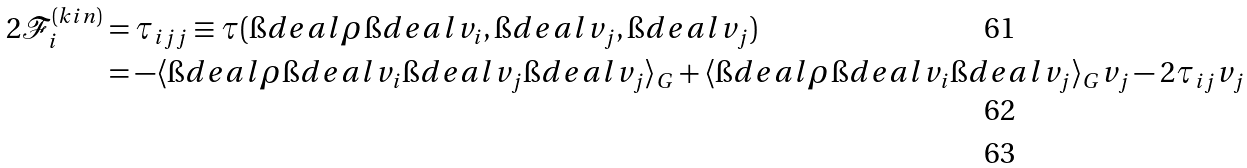<formula> <loc_0><loc_0><loc_500><loc_500>2 \mathcal { F } _ { i } ^ { ( k i n ) } & = \tau _ { i j j } \equiv \tau ( \i d e a l { \rho } \i d e a l { v _ { i } } , \i d e a l { v _ { j } } , \i d e a l { v _ { j } } ) \\ & = - \langle \i d e a l { \rho } \i d e a l { v _ { i } } \i d e a l { v _ { j } } \i d e a l { v _ { j } } \rangle _ { G } + \langle \i d e a l { \rho } \i d e a l { v _ { i } } \i d e a l { v _ { j } } \rangle _ { G } v _ { j } - 2 \tau _ { i j } v _ { j } \\</formula> 